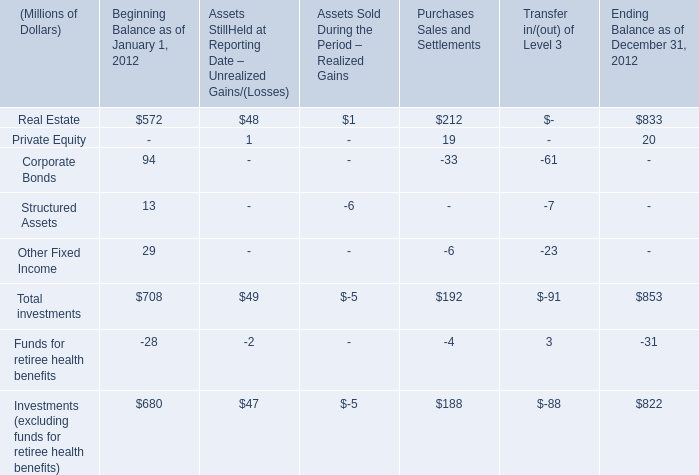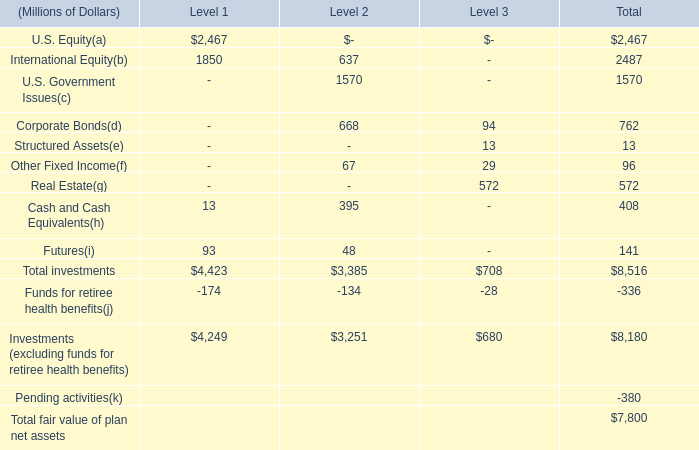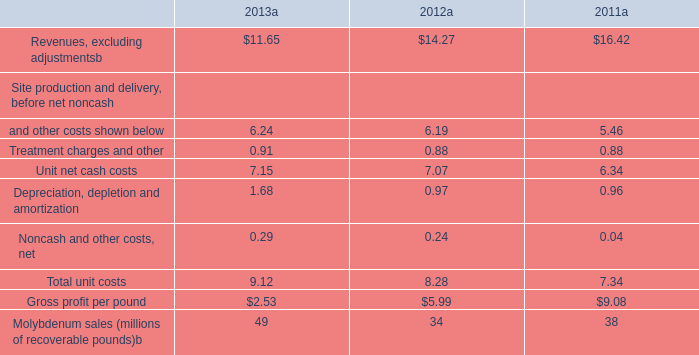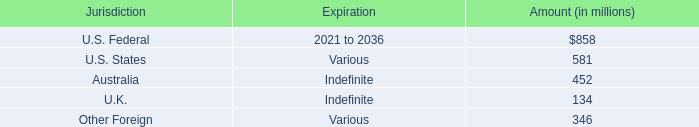what was the percentage change in the the company recorded a deferred tax asset associated with its nols from 2015 to 2016 
Computations: ((580 - 540) / 540)
Answer: 0.07407. 